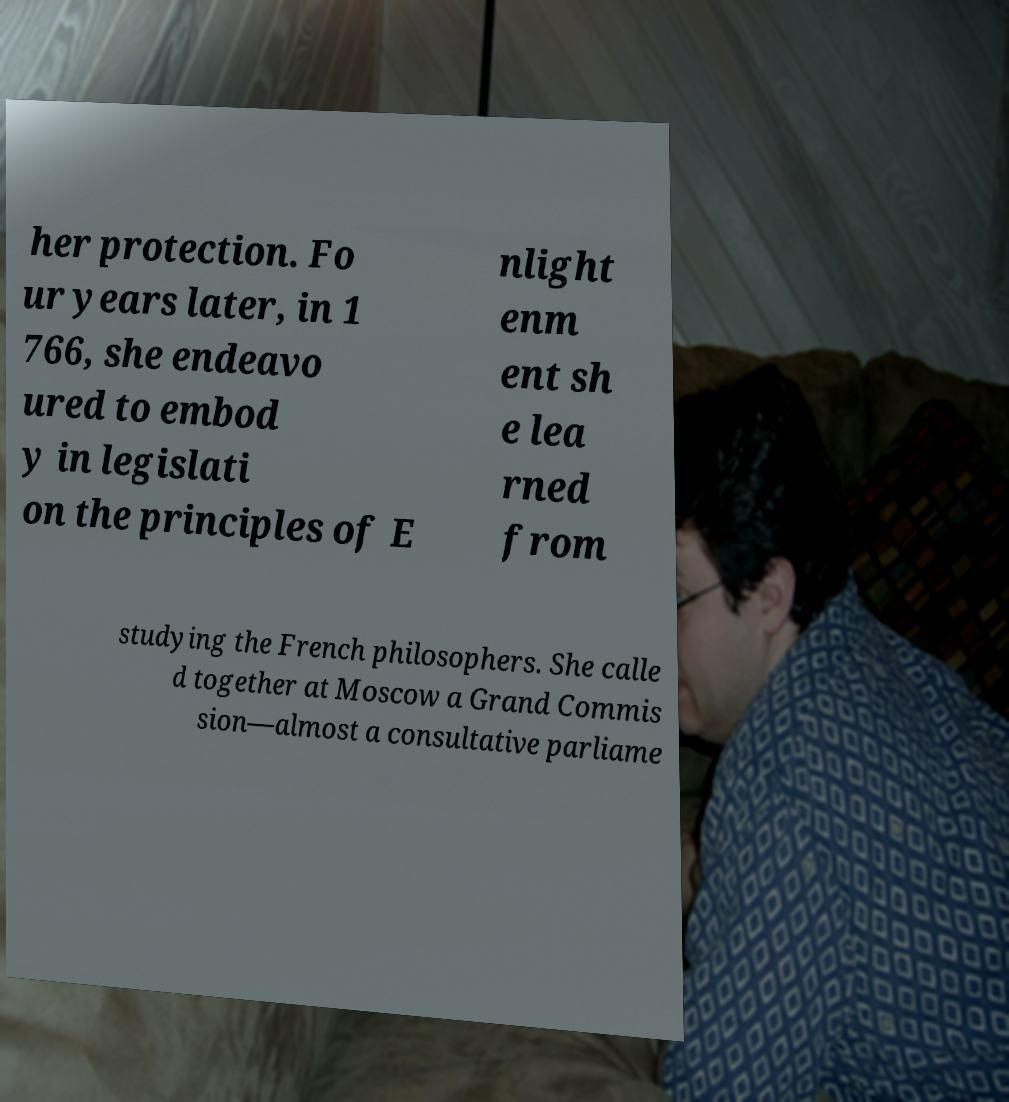Can you accurately transcribe the text from the provided image for me? her protection. Fo ur years later, in 1 766, she endeavo ured to embod y in legislati on the principles of E nlight enm ent sh e lea rned from studying the French philosophers. She calle d together at Moscow a Grand Commis sion—almost a consultative parliame 